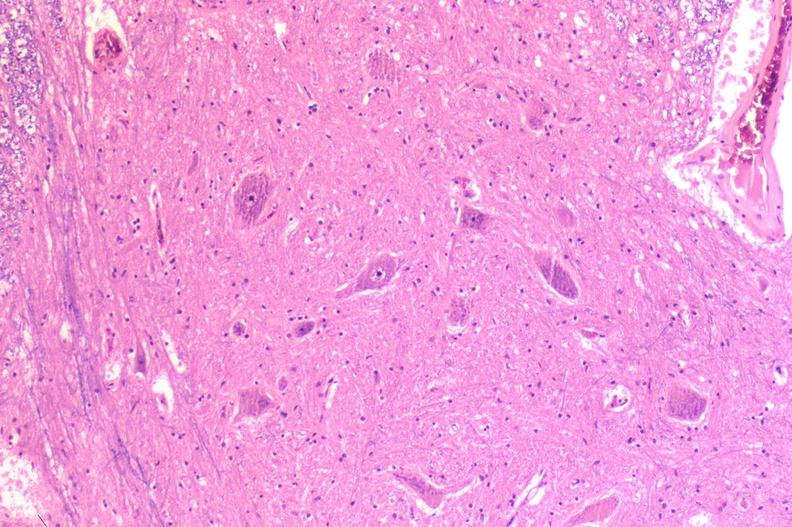s heart present?
Answer the question using a single word or phrase. No 